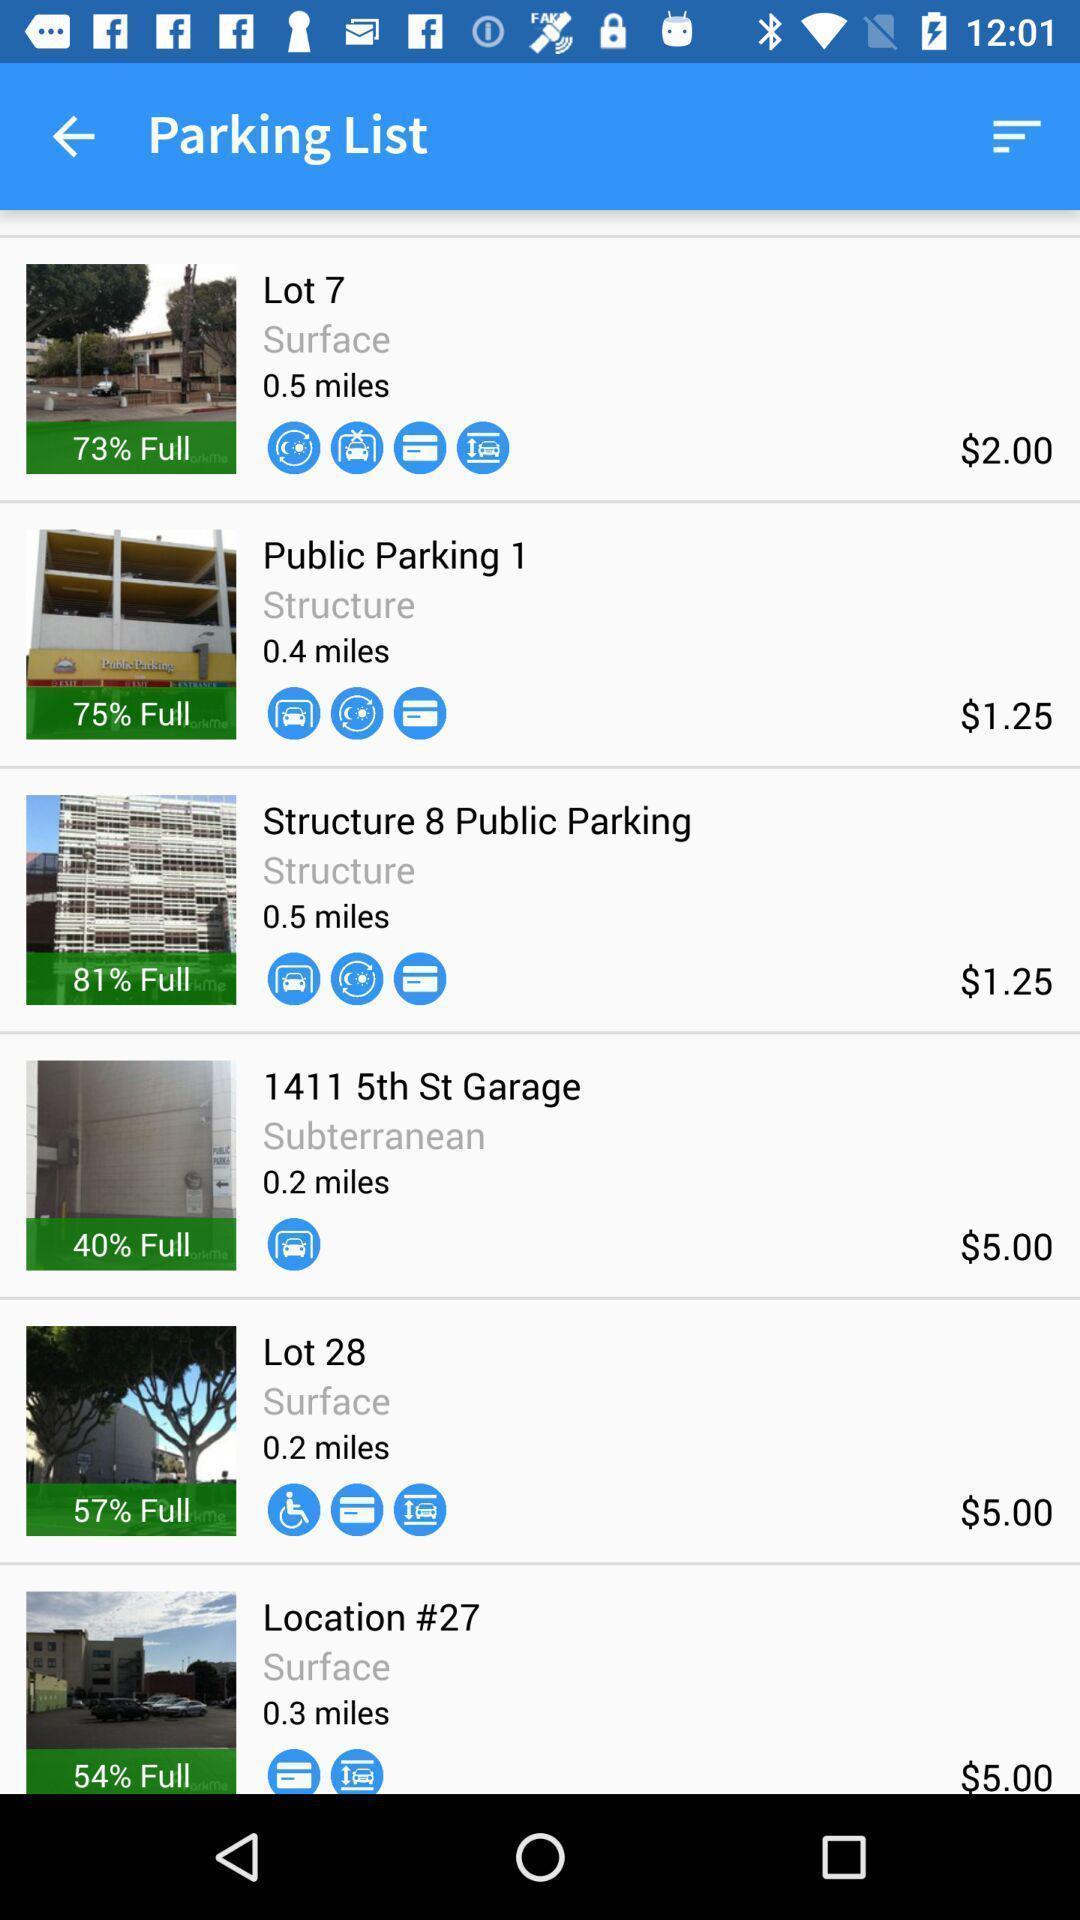Give me a narrative description of this picture. Page showing info in a vehicle parking related app. 